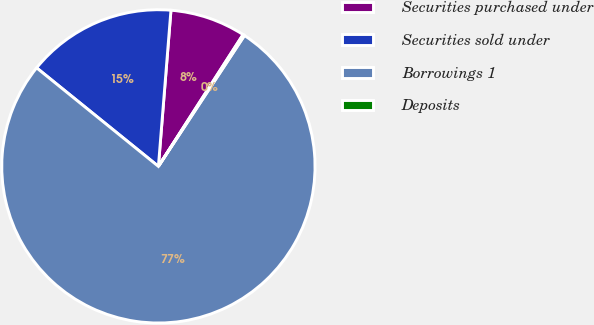Convert chart to OTSL. <chart><loc_0><loc_0><loc_500><loc_500><pie_chart><fcel>Securities purchased under<fcel>Securities sold under<fcel>Borrowings 1<fcel>Deposits<nl><fcel>7.81%<fcel>15.45%<fcel>76.56%<fcel>0.17%<nl></chart> 